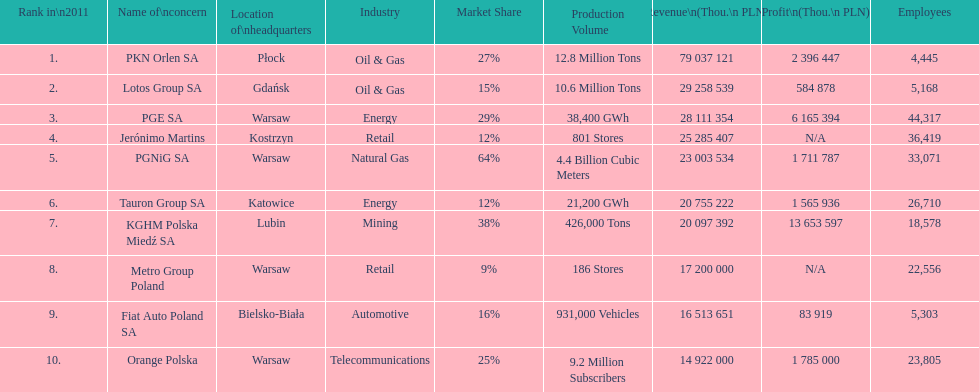Which company had the most revenue? PKN Orlen SA. 